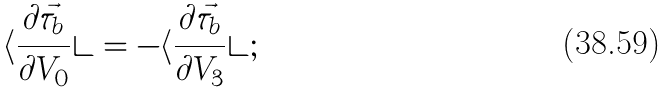Convert formula to latex. <formula><loc_0><loc_0><loc_500><loc_500>\langle \frac { \partial \vec { \tau } _ { b } } { \partial V _ { 0 } } \rangle = - \langle \frac { \partial \vec { \tau } _ { b } } { \partial V _ { 3 } } \rangle ;</formula> 